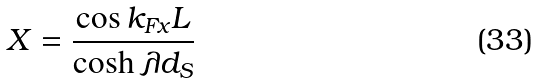<formula> <loc_0><loc_0><loc_500><loc_500>X = \frac { \cos k _ { F x } L } { \cosh \lambda d _ { S } }</formula> 